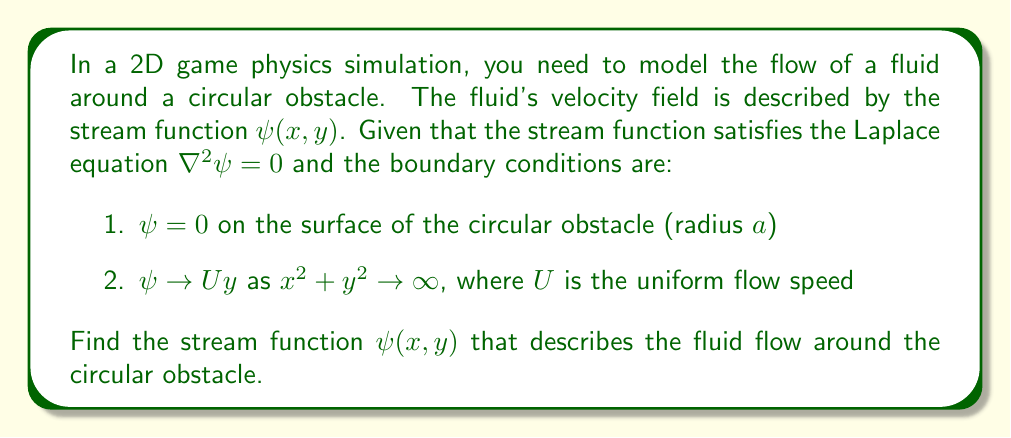Could you help me with this problem? To solve this problem, we'll use the method of separation of variables in polar coordinates.

1) First, we transform the Laplace equation into polar coordinates:

   $$\frac{1}{r}\frac{\partial}{\partial r}\left(r\frac{\partial \psi}{\partial r}\right) + \frac{1}{r^2}\frac{\partial^2 \psi}{\partial \theta^2} = 0$$

2) We assume a solution of the form $\psi(r,\theta) = R(r)\Theta(\theta)$

3) Substituting this into the Laplace equation and separating variables:

   $$\frac{r}{R}\frac{d}{dr}\left(r\frac{dR}{dr}\right) = -\frac{1}{\Theta}\frac{d^2\Theta}{d\theta^2} = \lambda$$

   where $\lambda$ is a separation constant.

4) The angular equation is:
   
   $$\frac{d^2\Theta}{d\theta^2} + \lambda\Theta = 0$$

   Its general solution is $\Theta(\theta) = A\cos(\sqrt{\lambda}\theta) + B\sin(\sqrt{\lambda}\theta)$

5) The radial equation is:

   $$r^2\frac{d^2R}{dr^2} + r\frac{dR}{dr} - \lambda R = 0$$

   Its general solution is $R(r) = Cr^\sqrt{\lambda} + Dr^{-\sqrt{\lambda}}$

6) To satisfy the boundary conditions, we need $\lambda = 1$. Thus, the general solution is:

   $$\psi(r,\theta) = (Ar + \frac{B}{r})\sin\theta$$

7) Applying the boundary conditions:

   At $r = a$: $\psi(a,\theta) = 0 \implies Aa + \frac{B}{a} = 0$
   
   As $r \rightarrow \infty$: $\psi \rightarrow Ur\sin\theta \implies A = U$

8) Solving these equations:

   $A = U$ and $B = -Ua^2$

Therefore, the stream function is:

$$\psi(r,\theta) = U(r - \frac{a^2}{r})\sin\theta$$

In Cartesian coordinates, this becomes:

$$\psi(x,y) = U(y - \frac{a^2y}{x^2+y^2})$$
Answer: $$\psi(x,y) = U(y - \frac{a^2y}{x^2+y^2})$$ 